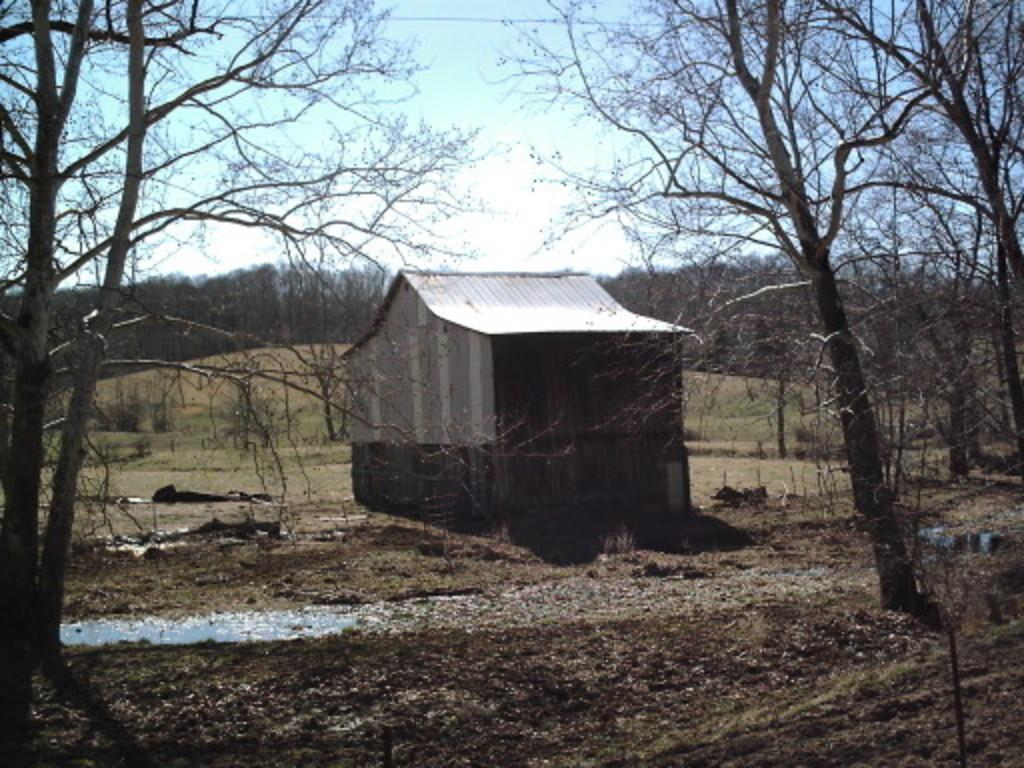What type of structure is visible in the image? There is a house in the image. What type of vegetation can be seen in the image? There are trees and plants in the image. What natural element is visible in the image? There is water visible in the image. What is present on the ground in the image? Dry leaves are present on the ground. What is visible in the background of the image? The sky is visible in the background of the image. What type of chess piece can be seen on the roof of the house in the image? There is no chess piece visible on the roof of the house in the image. What type of cable is connected to the trees in the image? There is no cable connected to the trees in the image. 